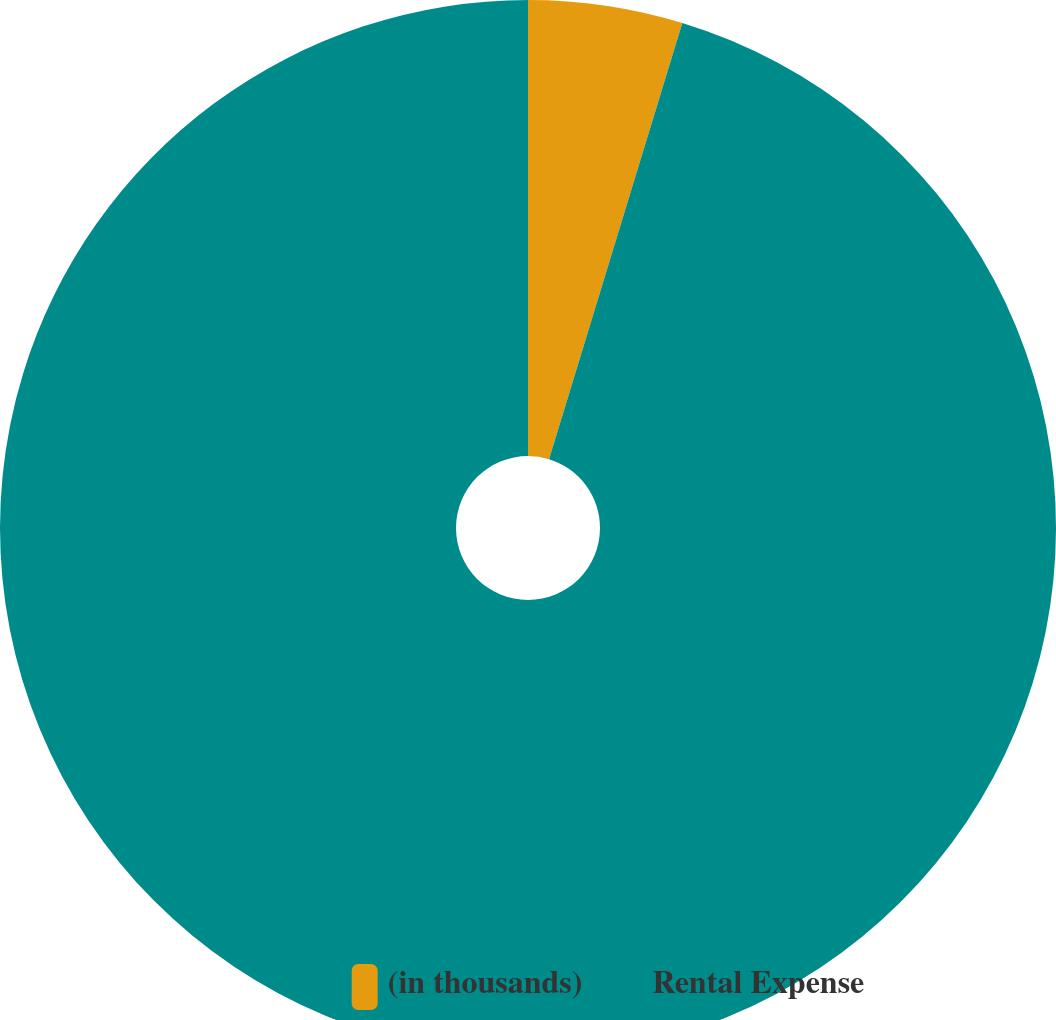<chart> <loc_0><loc_0><loc_500><loc_500><pie_chart><fcel>(in thousands)<fcel>Rental Expense<nl><fcel>4.72%<fcel>95.28%<nl></chart> 